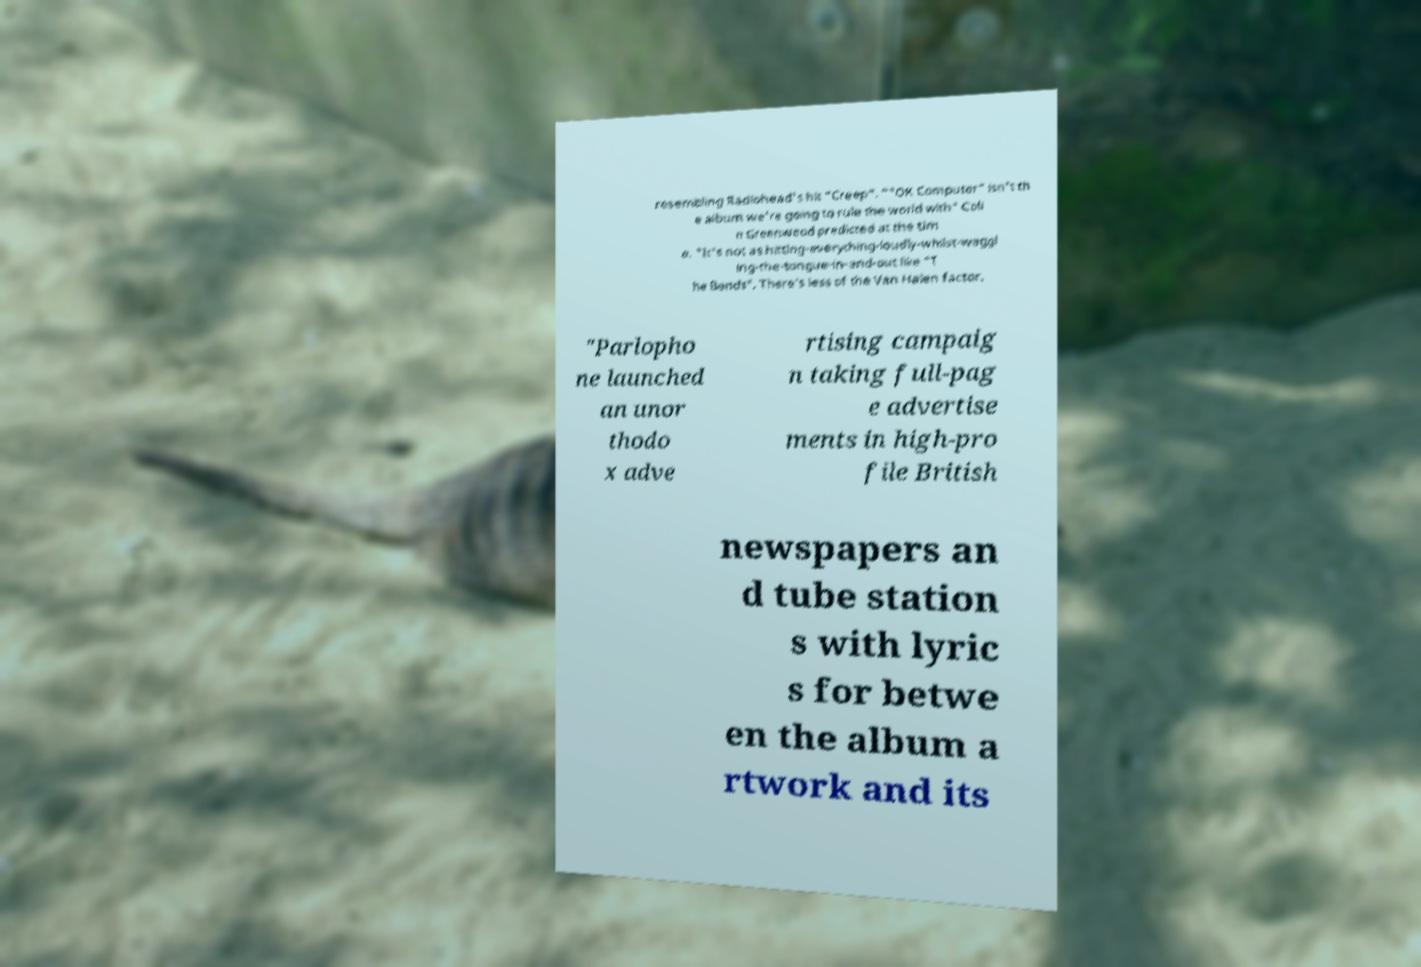What messages or text are displayed in this image? I need them in a readable, typed format. resembling Radiohead's hit "Creep". ""OK Computer" isn't th e album we're going to rule the world with" Coli n Greenwood predicted at the tim e. "It's not as hitting-everything-loudly-whilst-waggl ing-the-tongue-in-and-out like "T he Bends". There's less of the Van Halen factor. "Parlopho ne launched an unor thodo x adve rtising campaig n taking full-pag e advertise ments in high-pro file British newspapers an d tube station s with lyric s for betwe en the album a rtwork and its 